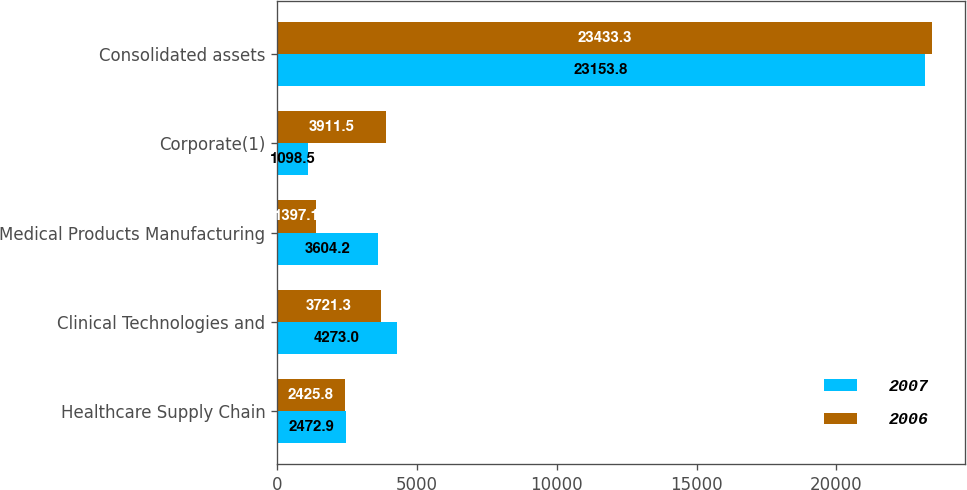Convert chart to OTSL. <chart><loc_0><loc_0><loc_500><loc_500><stacked_bar_chart><ecel><fcel>Healthcare Supply Chain<fcel>Clinical Technologies and<fcel>Medical Products Manufacturing<fcel>Corporate(1)<fcel>Consolidated assets<nl><fcel>2007<fcel>2472.9<fcel>4273<fcel>3604.2<fcel>1098.5<fcel>23153.8<nl><fcel>2006<fcel>2425.8<fcel>3721.3<fcel>1397.1<fcel>3911.5<fcel>23433.3<nl></chart> 